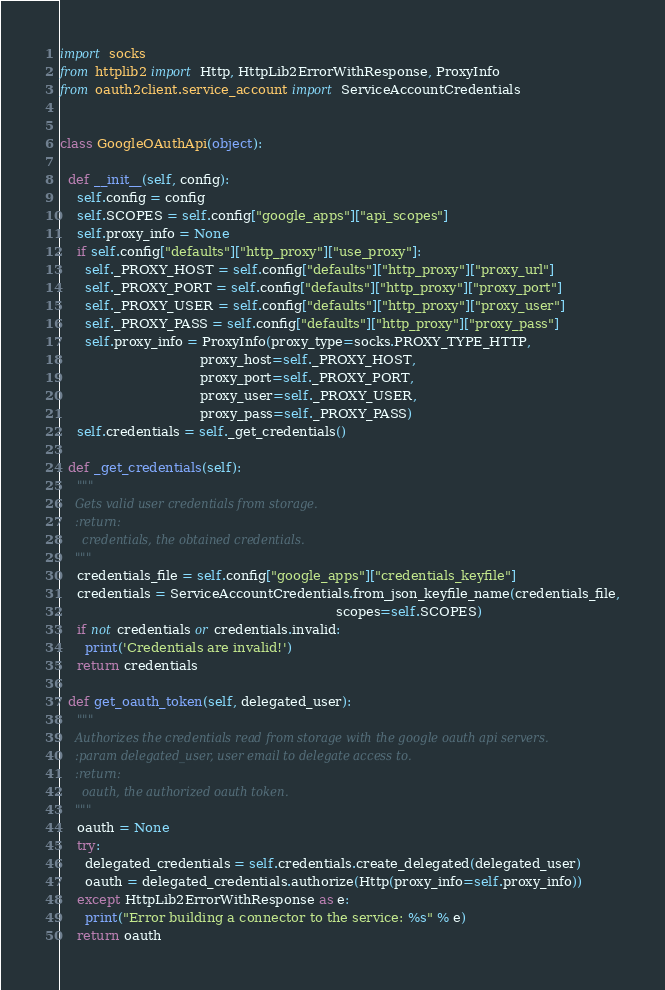Convert code to text. <code><loc_0><loc_0><loc_500><loc_500><_Python_>import socks
from httplib2 import Http, HttpLib2ErrorWithResponse, ProxyInfo
from oauth2client.service_account import ServiceAccountCredentials


class GoogleOAuthApi(object):

  def __init__(self, config):
    self.config = config
    self.SCOPES = self.config["google_apps"]["api_scopes"]
    self.proxy_info = None
    if self.config["defaults"]["http_proxy"]["use_proxy"]:
      self._PROXY_HOST = self.config["defaults"]["http_proxy"]["proxy_url"]
      self._PROXY_PORT = self.config["defaults"]["http_proxy"]["proxy_port"]
      self._PROXY_USER = self.config["defaults"]["http_proxy"]["proxy_user"]
      self._PROXY_PASS = self.config["defaults"]["http_proxy"]["proxy_pass"]
      self.proxy_info = ProxyInfo(proxy_type=socks.PROXY_TYPE_HTTP,
                                  proxy_host=self._PROXY_HOST,
                                  proxy_port=self._PROXY_PORT,
                                  proxy_user=self._PROXY_USER,
                                  proxy_pass=self._PROXY_PASS)
    self.credentials = self._get_credentials()

  def _get_credentials(self):
    """
    Gets valid user credentials from storage.
    :return:
      credentials, the obtained credentials.
    """
    credentials_file = self.config["google_apps"]["credentials_keyfile"]
    credentials = ServiceAccountCredentials.from_json_keyfile_name(credentials_file,
                                                                   scopes=self.SCOPES)
    if not credentials or credentials.invalid:
      print('Credentials are invalid!')
    return credentials

  def get_oauth_token(self, delegated_user):
    """
    Authorizes the credentials read from storage with the google oauth api servers.
    :param delegated_user, user email to delegate access to.
    :return:
      oauth, the authorized oauth token.
    """
    oauth = None
    try:
      delegated_credentials = self.credentials.create_delegated(delegated_user)
      oauth = delegated_credentials.authorize(Http(proxy_info=self.proxy_info))
    except HttpLib2ErrorWithResponse as e:
      print("Error building a connector to the service: %s" % e)
    return oauth
</code> 